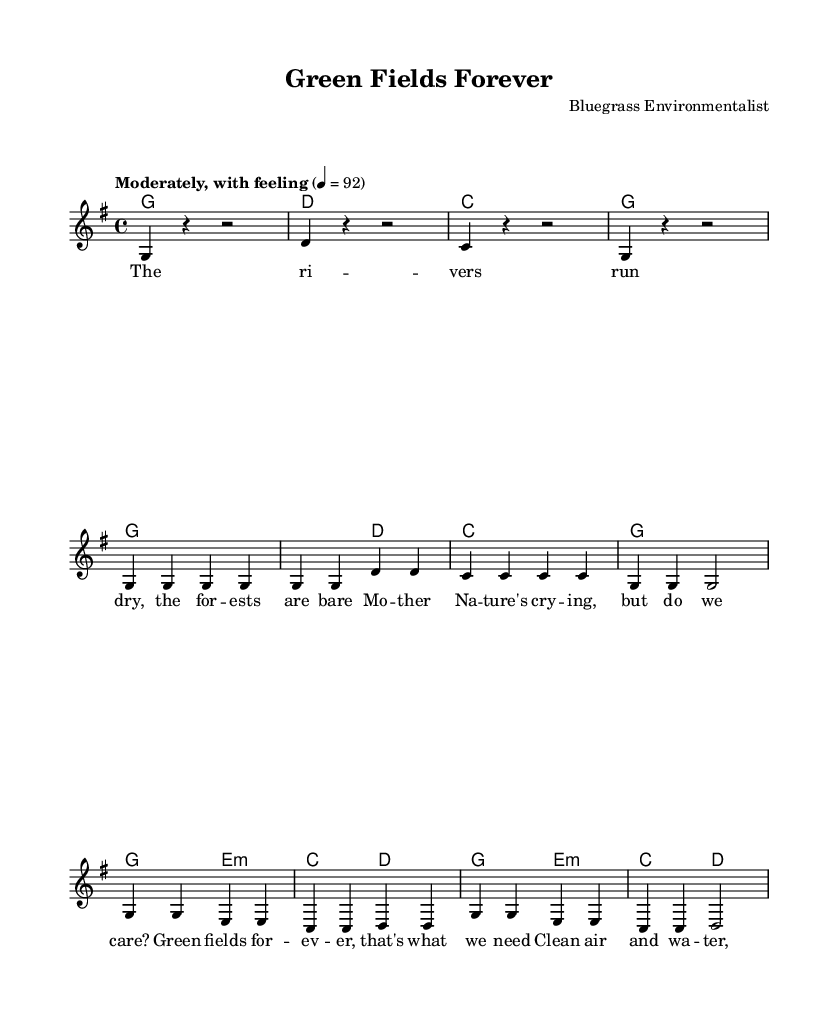What is the key signature of this music? The key signature indicated is one sharp, which corresponds to the G major scale. This can be seen at the beginning of the staff on the left side, where it shows the position of the sharp sign.
Answer: G major What is the time signature of this music? The time signature is indicated right after the key signature at the beginning of the staff. It shows "4/4", meaning there are four beats per measure, and the quarter note gets one beat.
Answer: 4/4 What is the tempo marking for this piece? The tempo marking appears at the beginning, stating "Moderately, with feeling" followed by a metronome marking of "4 = 92". This indicates how fast the piece should be played.
Answer: Moderately, with feeling What are the first two notes of the melody? The first two notes in the melody are both G notes (g4) as seen in the introductory measures. The "g4" indicates the pitch and octave of the note.
Answer: G, G How many measures are in the verse of this song? The verse, as shown in the sheet music, consists of 4 complete measures that are notated under the melody section. This can be counted in the lyrics section and matched with the music measures.
Answer: 4 What is the chord progression for the first line of the verse? The first line of the verse has a chord progression of G, D, C, and G, which can be identified from the chord section directly above the lyrics. Each chord corresponds to the respective lyric syllables.
Answer: G, D, C, G Which phrase indicates the theme of environmental conservation in the lyrics? The line "Clean air and water, let's plant the seeds" explicitly suggests the theme of environmental conservation. It reflects the message of caring for nature and supporting the environment.
Answer: Clean air and water, let's plant the seeds 